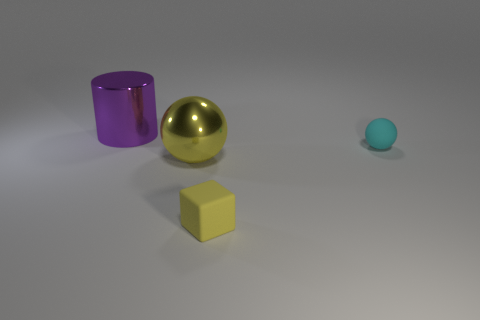There is a small yellow block; how many metal cylinders are behind it?
Offer a terse response. 1. Are there the same number of tiny balls that are in front of the yellow matte object and rubber spheres on the left side of the large yellow metal ball?
Give a very brief answer. Yes. The other metal thing that is the same shape as the cyan object is what size?
Offer a very short reply. Large. The large shiny object in front of the big purple metallic cylinder has what shape?
Your response must be concise. Sphere. Do the small thing that is in front of the small ball and the sphere that is right of the large sphere have the same material?
Your answer should be very brief. Yes. What shape is the yellow rubber thing?
Keep it short and to the point. Cube. Are there the same number of metal cylinders that are to the left of the purple thing and small rubber blocks?
Your answer should be compact. No. The thing that is the same color as the cube is what size?
Provide a short and direct response. Large. Are there any small cylinders that have the same material as the cyan ball?
Your answer should be compact. No. There is a shiny thing behind the big ball; is its shape the same as the big shiny object in front of the tiny cyan sphere?
Offer a terse response. No. 